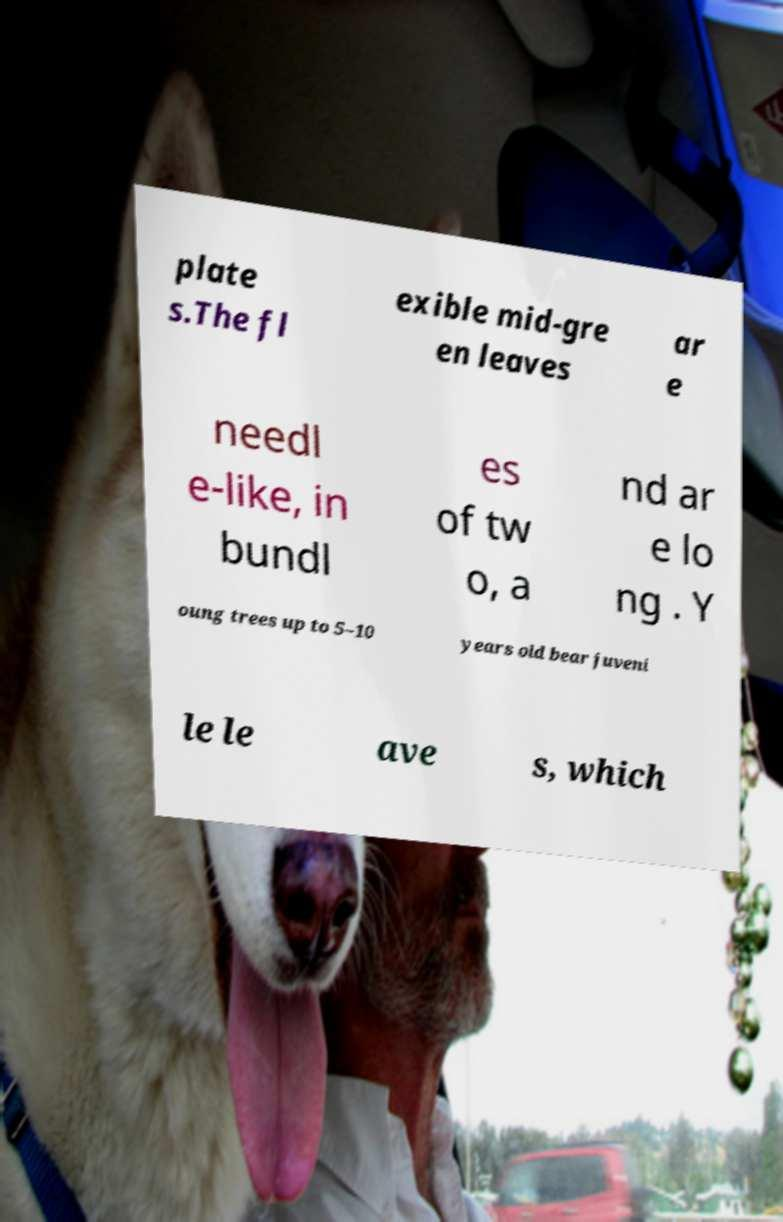What messages or text are displayed in this image? I need them in a readable, typed format. plate s.The fl exible mid-gre en leaves ar e needl e-like, in bundl es of tw o, a nd ar e lo ng . Y oung trees up to 5–10 years old bear juveni le le ave s, which 